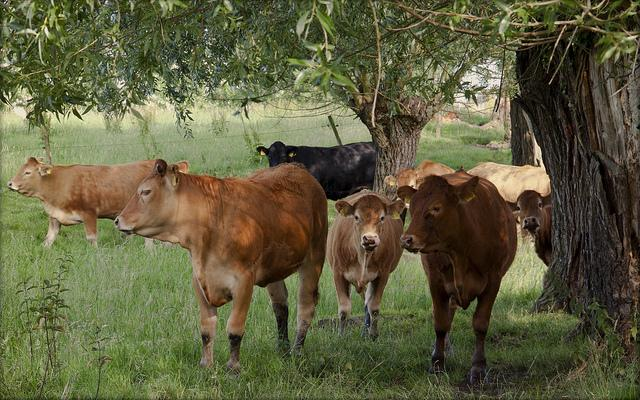What is the young offspring of these animals called? calf 